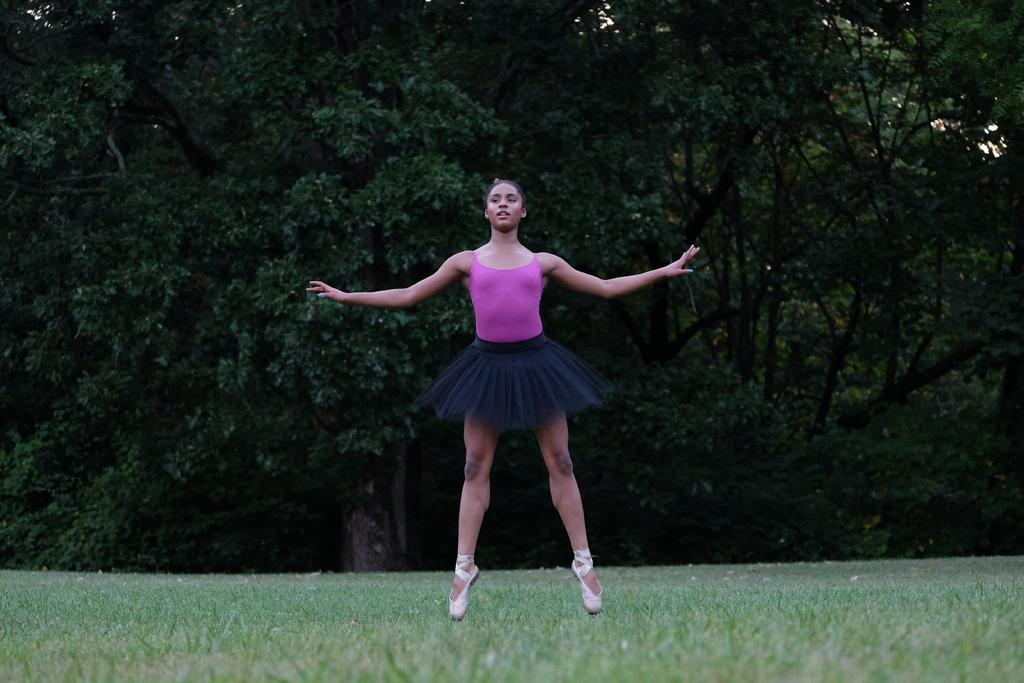What type of vegetation can be seen in the background of the image? There are trees in the background of the image. Who is present in the image? There is a girl in the image. What is the girl wearing? The girl is wearing a black skirt. What is the girl doing in the image? The girl is standing on her toes. What is the ground surface like in the image? There is grass visible in the image. How many yaks can be seen in the image? There are no yaks present in the image. What color are the girl's eyes in the image? The provided facts do not mention the color of the girl's eyes, so we cannot determine that information from the image. 